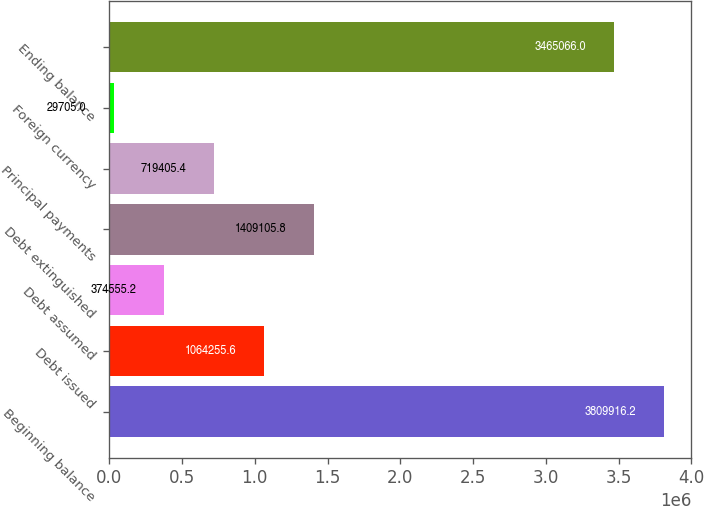Convert chart to OTSL. <chart><loc_0><loc_0><loc_500><loc_500><bar_chart><fcel>Beginning balance<fcel>Debt issued<fcel>Debt assumed<fcel>Debt extinguished<fcel>Principal payments<fcel>Foreign currency<fcel>Ending balance<nl><fcel>3.80992e+06<fcel>1.06426e+06<fcel>374555<fcel>1.40911e+06<fcel>719405<fcel>29705<fcel>3.46507e+06<nl></chart> 